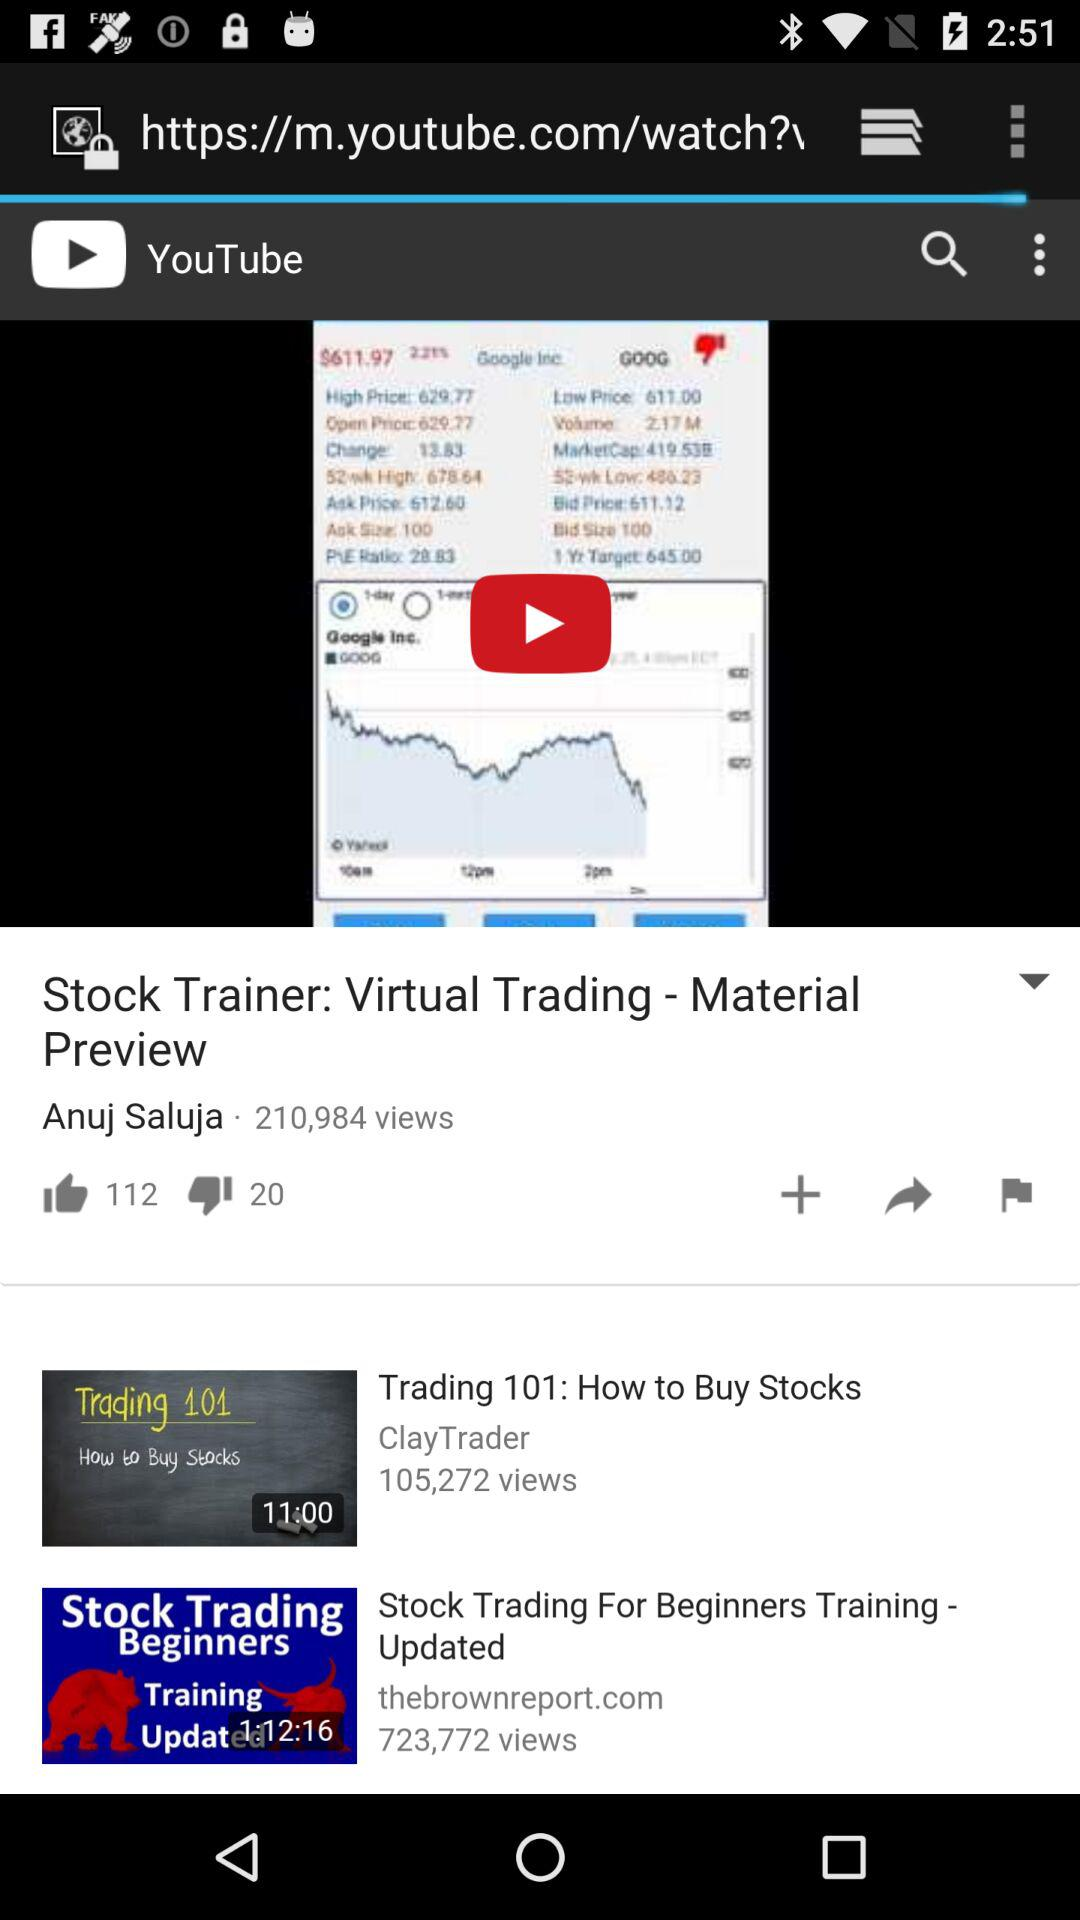How many views on the video?
Answer the question using a single word or phrase. There are 210,984 views on the video 